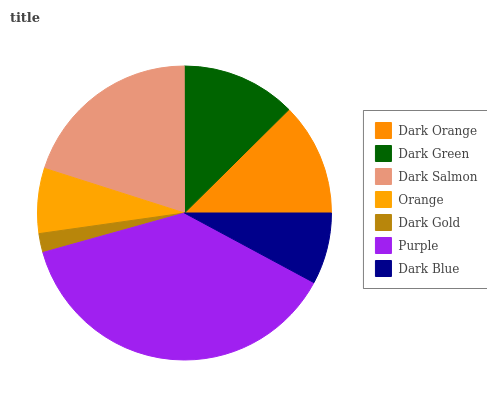Is Dark Gold the minimum?
Answer yes or no. Yes. Is Purple the maximum?
Answer yes or no. Yes. Is Dark Green the minimum?
Answer yes or no. No. Is Dark Green the maximum?
Answer yes or no. No. Is Dark Green greater than Dark Orange?
Answer yes or no. Yes. Is Dark Orange less than Dark Green?
Answer yes or no. Yes. Is Dark Orange greater than Dark Green?
Answer yes or no. No. Is Dark Green less than Dark Orange?
Answer yes or no. No. Is Dark Orange the high median?
Answer yes or no. Yes. Is Dark Orange the low median?
Answer yes or no. Yes. Is Dark Blue the high median?
Answer yes or no. No. Is Dark Blue the low median?
Answer yes or no. No. 